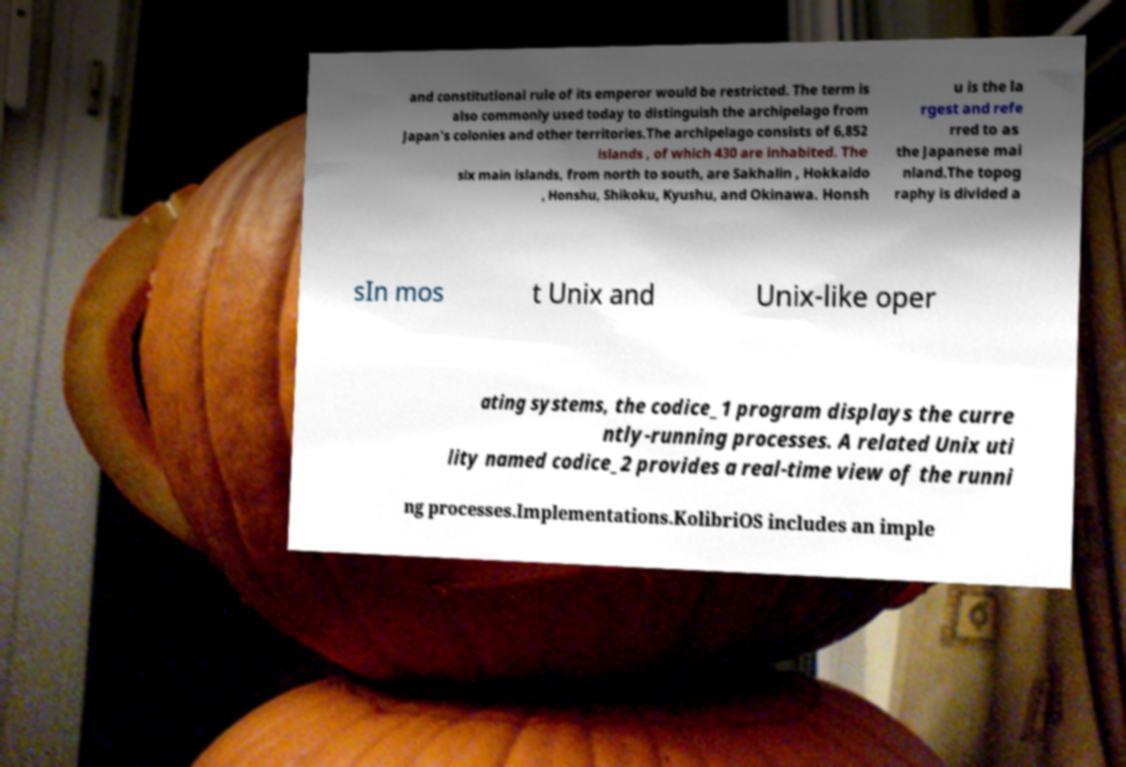There's text embedded in this image that I need extracted. Can you transcribe it verbatim? and constitutional rule of its emperor would be restricted. The term is also commonly used today to distinguish the archipelago from Japan's colonies and other territories.The archipelago consists of 6,852 islands , of which 430 are inhabited. The six main islands, from north to south, are Sakhalin , Hokkaido , Honshu, Shikoku, Kyushu, and Okinawa. Honsh u is the la rgest and refe rred to as the Japanese mai nland.The topog raphy is divided a sIn mos t Unix and Unix-like oper ating systems, the codice_1 program displays the curre ntly-running processes. A related Unix uti lity named codice_2 provides a real-time view of the runni ng processes.Implementations.KolibriOS includes an imple 